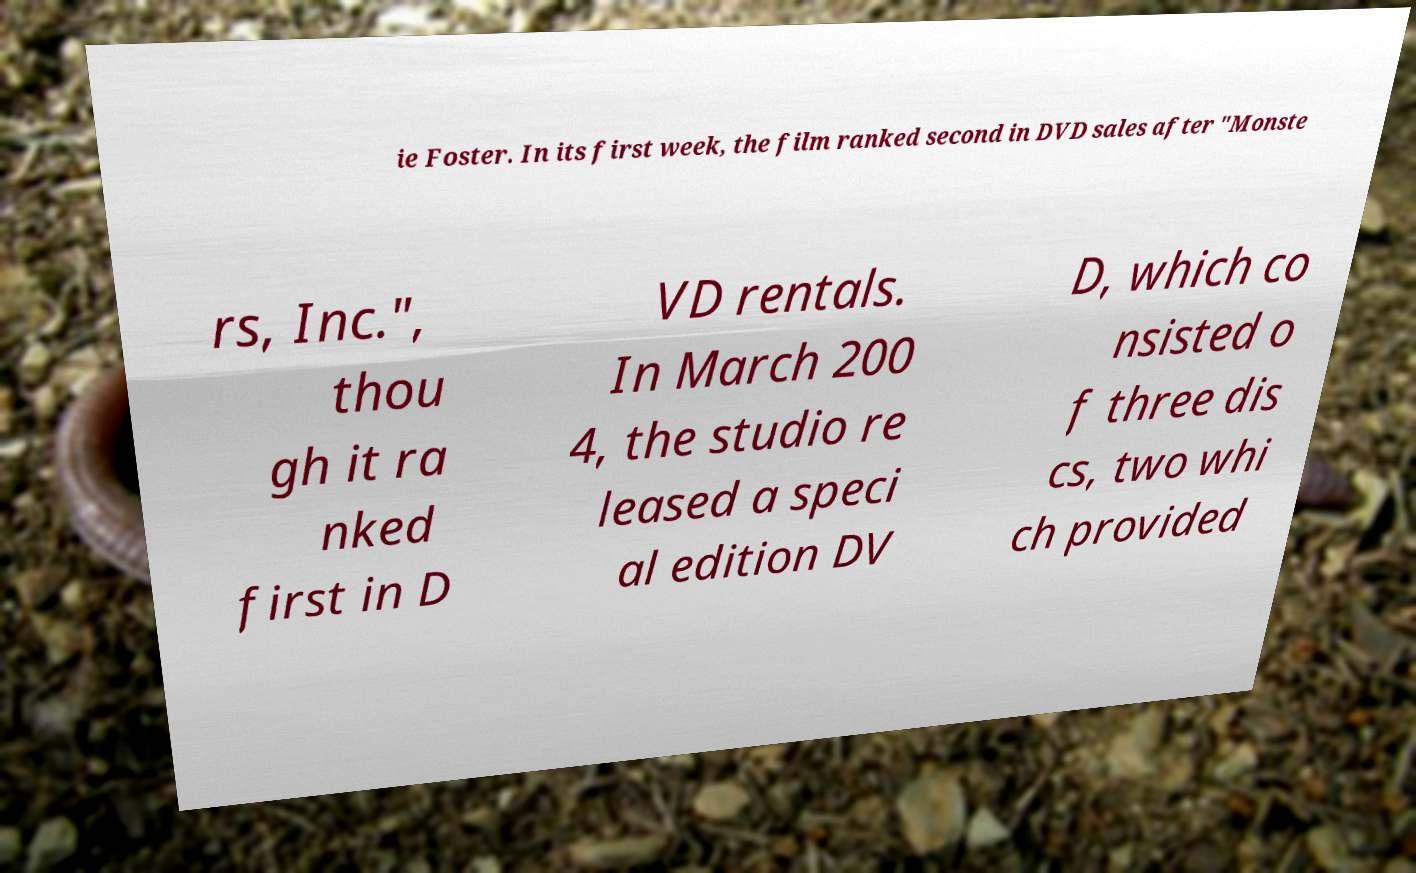Please read and relay the text visible in this image. What does it say? ie Foster. In its first week, the film ranked second in DVD sales after "Monste rs, Inc.", thou gh it ra nked first in D VD rentals. In March 200 4, the studio re leased a speci al edition DV D, which co nsisted o f three dis cs, two whi ch provided 